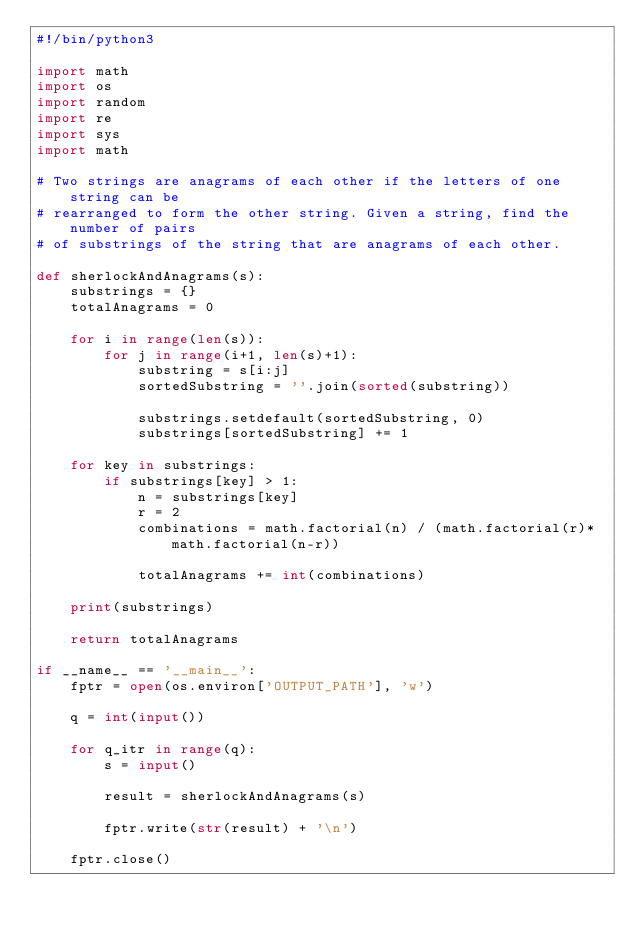<code> <loc_0><loc_0><loc_500><loc_500><_Python_>#!/bin/python3

import math
import os
import random
import re
import sys
import math

# Two strings are anagrams of each other if the letters of one string can be 
# rearranged to form the other string. Given a string, find the number of pairs 
# of substrings of the string that are anagrams of each other.

def sherlockAndAnagrams(s):
    substrings = {}
    totalAnagrams = 0

    for i in range(len(s)):
        for j in range(i+1, len(s)+1):
            substring = s[i:j]
            sortedSubstring = ''.join(sorted(substring))

            substrings.setdefault(sortedSubstring, 0)
            substrings[sortedSubstring] += 1

    for key in substrings:
        if substrings[key] > 1:
            n = substrings[key]
            r = 2
            combinations = math.factorial(n) / (math.factorial(r)*math.factorial(n-r))

            totalAnagrams += int(combinations)

    print(substrings)

    return totalAnagrams

if __name__ == '__main__':
    fptr = open(os.environ['OUTPUT_PATH'], 'w')

    q = int(input())

    for q_itr in range(q):
        s = input()

        result = sherlockAndAnagrams(s)

        fptr.write(str(result) + '\n')

    fptr.close()
</code> 